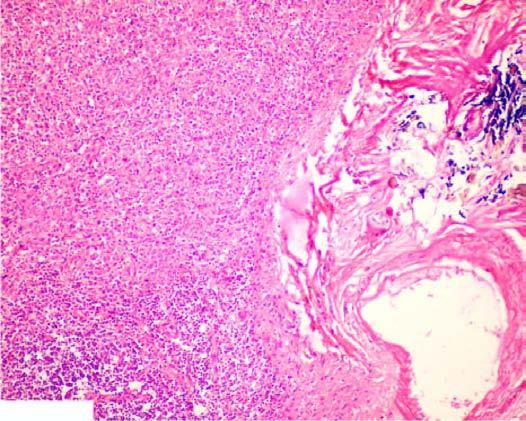s part of the oesophagus which is normally lined by squamous epithelium also seen?
Answer the question using a single word or phrase. No 